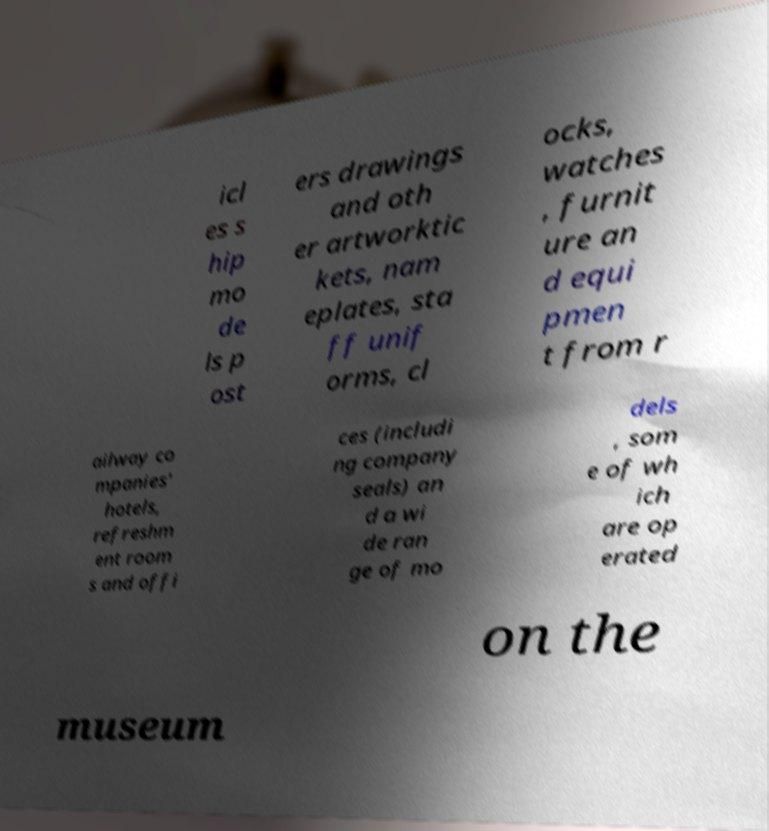Please identify and transcribe the text found in this image. icl es s hip mo de ls p ost ers drawings and oth er artworktic kets, nam eplates, sta ff unif orms, cl ocks, watches , furnit ure an d equi pmen t from r ailway co mpanies' hotels, refreshm ent room s and offi ces (includi ng company seals) an d a wi de ran ge of mo dels , som e of wh ich are op erated on the museum 